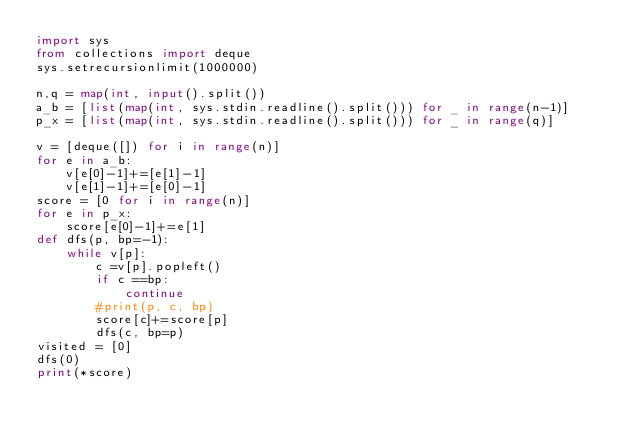<code> <loc_0><loc_0><loc_500><loc_500><_Python_>import sys
from collections import deque
sys.setrecursionlimit(1000000)

n,q = map(int, input().split())
a_b = [list(map(int, sys.stdin.readline().split())) for _ in range(n-1)]
p_x = [list(map(int, sys.stdin.readline().split())) for _ in range(q)]

v = [deque([]) for i in range(n)]
for e in a_b:
    v[e[0]-1]+=[e[1]-1]
    v[e[1]-1]+=[e[0]-1]
score = [0 for i in range(n)]
for e in p_x:
    score[e[0]-1]+=e[1]
def dfs(p, bp=-1):
    while v[p]:
        c =v[p].popleft()
        if c ==bp:
            continue
        #print(p, c, bp)
        score[c]+=score[p]
        dfs(c, bp=p)
visited = [0]                
dfs(0)
print(*score)</code> 